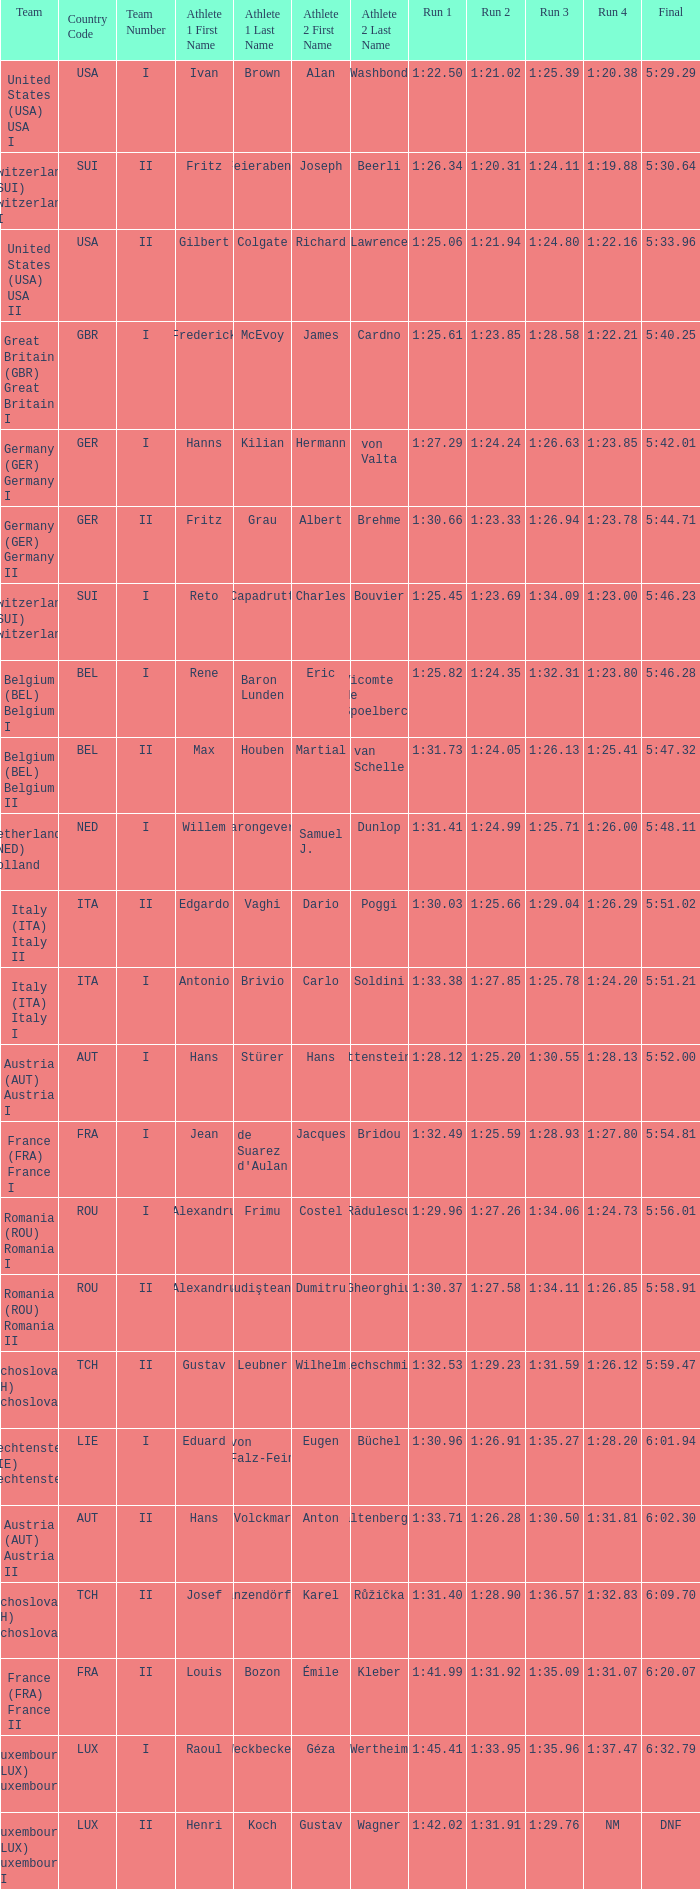Which Run 4 has a Run 3 of 1:26.63? 1:23.85. 